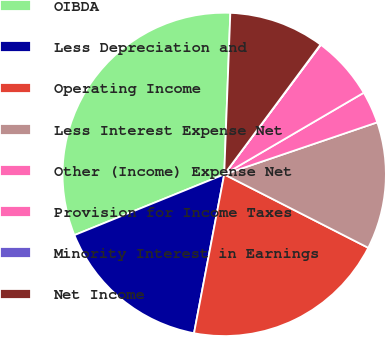Convert chart. <chart><loc_0><loc_0><loc_500><loc_500><pie_chart><fcel>OIBDA<fcel>Less Depreciation and<fcel>Operating Income<fcel>Less Interest Expense Net<fcel>Other (Income) Expense Net<fcel>Provision for Income Taxes<fcel>Minority Interest in Earnings<fcel>Net Income<nl><fcel>31.73%<fcel>15.88%<fcel>20.49%<fcel>12.72%<fcel>3.21%<fcel>6.38%<fcel>0.04%<fcel>9.55%<nl></chart> 